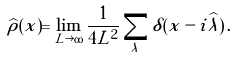Convert formula to latex. <formula><loc_0><loc_0><loc_500><loc_500>\widehat { \rho } ( x ) = \lim _ { L \rightarrow \infty } \frac { 1 } { 4 L ^ { 2 } } \sum _ { \lambda } \delta ( x - i \widehat { \lambda } ) \, .</formula> 